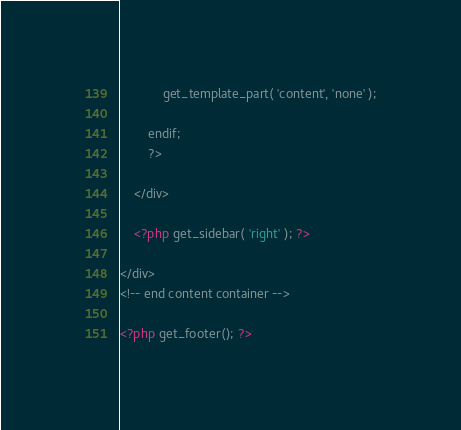Convert code to text. <code><loc_0><loc_0><loc_500><loc_500><_PHP_>
			get_template_part( 'content', 'none' );

		endif;
		?>

	</div>

	<?php get_sidebar( 'right' ); ?>

</div>
<!-- end content container -->

<?php get_footer(); ?>
</code> 